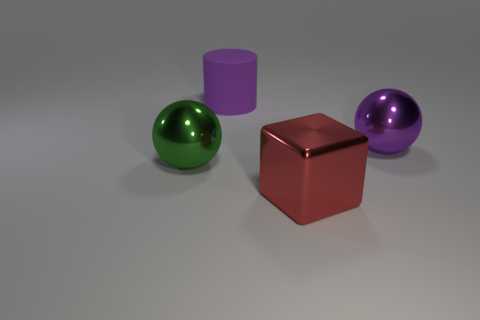Imagine these objects are characters in a story. What personalities might they have? The sphere could be seen as outgoing and dynamic, reflecting its surroundings with optimism. The cylinder might be the strong, silent type—stable and reliable. The cube could represent a grounded, pragmatic character, with its solid sides providing a steady base. Lastly, the second sphere might be the counterpart or twin to the first sphere, with a similar yet individual distinctness in its hue and sheen, perhaps a little more reserved or introspective. 